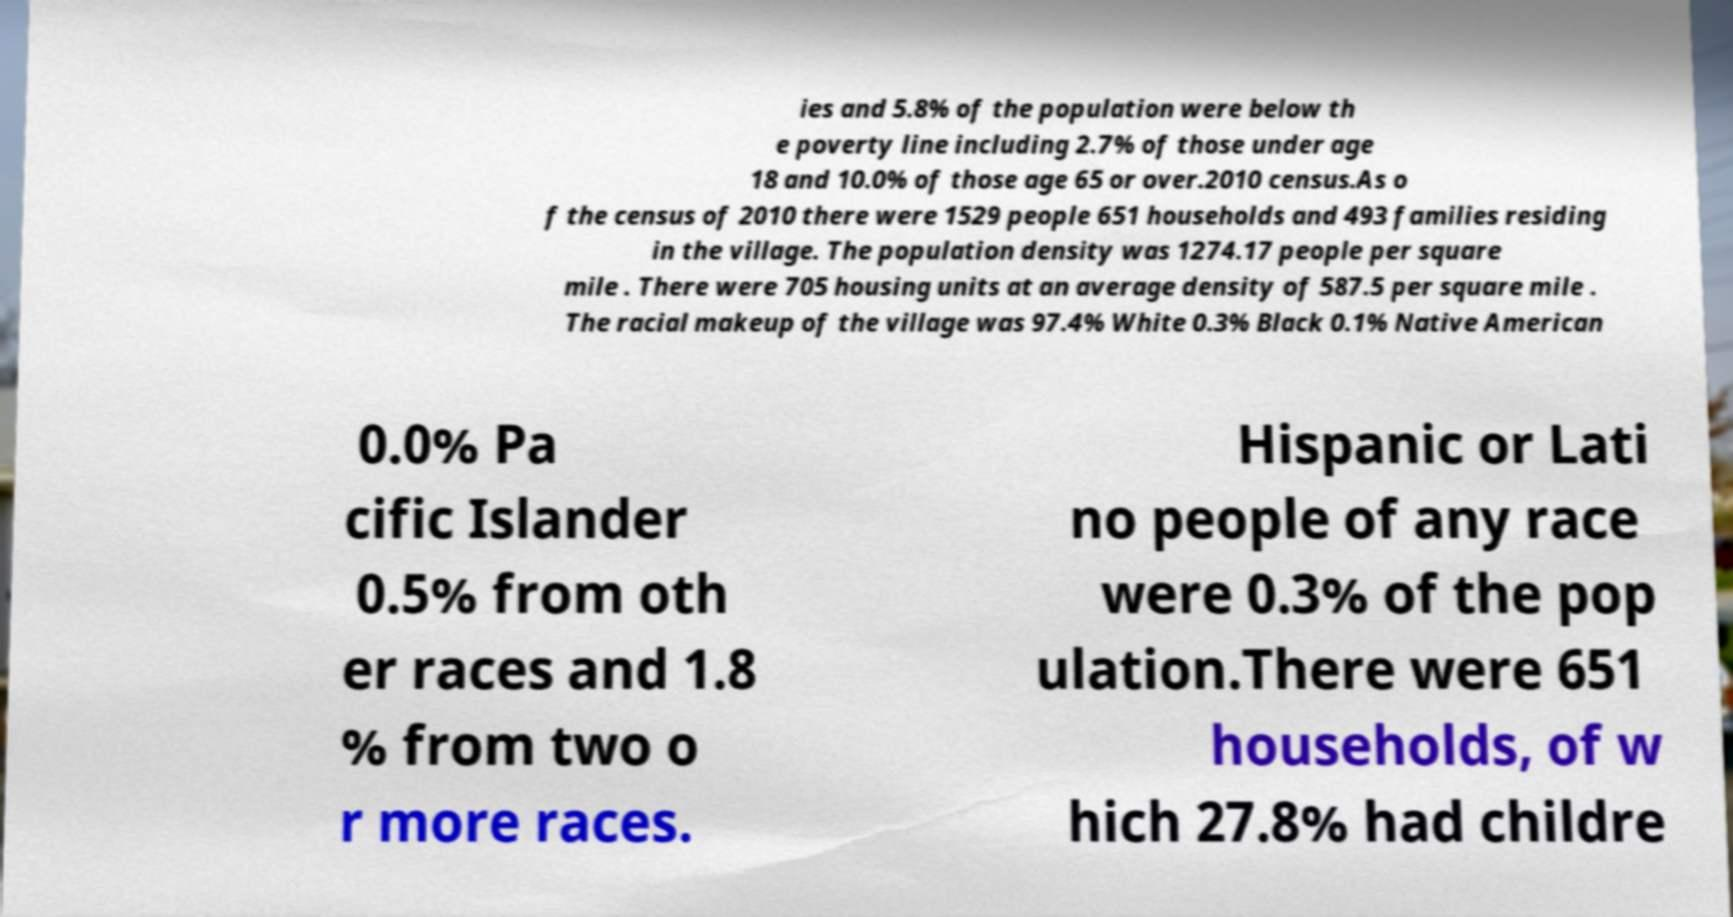Please read and relay the text visible in this image. What does it say? ies and 5.8% of the population were below th e poverty line including 2.7% of those under age 18 and 10.0% of those age 65 or over.2010 census.As o f the census of 2010 there were 1529 people 651 households and 493 families residing in the village. The population density was 1274.17 people per square mile . There were 705 housing units at an average density of 587.5 per square mile . The racial makeup of the village was 97.4% White 0.3% Black 0.1% Native American 0.0% Pa cific Islander 0.5% from oth er races and 1.8 % from two o r more races. Hispanic or Lati no people of any race were 0.3% of the pop ulation.There were 651 households, of w hich 27.8% had childre 